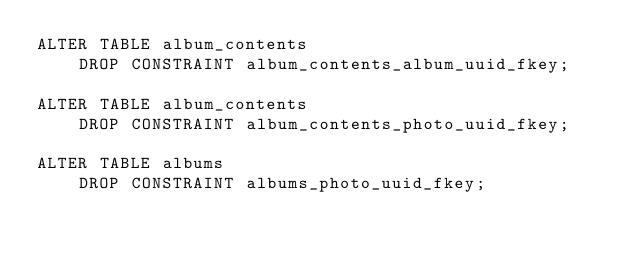<code> <loc_0><loc_0><loc_500><loc_500><_SQL_>ALTER TABLE album_contents
    DROP CONSTRAINT album_contents_album_uuid_fkey;

ALTER TABLE album_contents
    DROP CONSTRAINT album_contents_photo_uuid_fkey;

ALTER TABLE albums
    DROP CONSTRAINT albums_photo_uuid_fkey;
</code> 